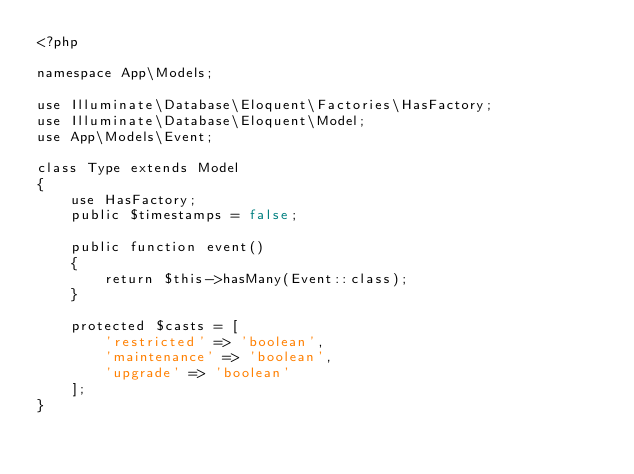<code> <loc_0><loc_0><loc_500><loc_500><_PHP_><?php

namespace App\Models;

use Illuminate\Database\Eloquent\Factories\HasFactory;
use Illuminate\Database\Eloquent\Model;
use App\Models\Event;

class Type extends Model
{
    use HasFactory;
    public $timestamps = false;

    public function event()
    {
        return $this->hasMany(Event::class);
    }

    protected $casts = [
        'restricted' => 'boolean',
        'maintenance' => 'boolean',
        'upgrade' => 'boolean'
    ];
}
</code> 